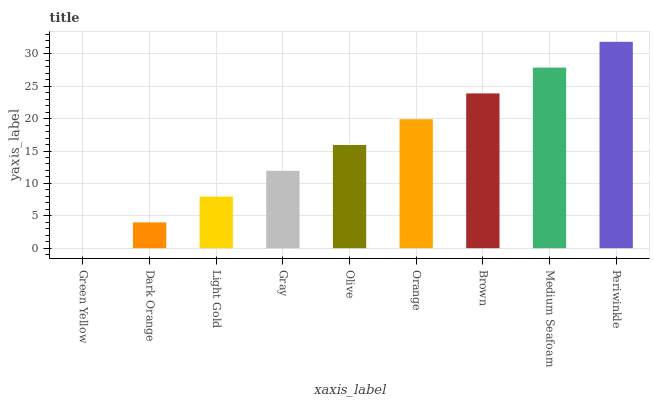Is Green Yellow the minimum?
Answer yes or no. Yes. Is Periwinkle the maximum?
Answer yes or no. Yes. Is Dark Orange the minimum?
Answer yes or no. No. Is Dark Orange the maximum?
Answer yes or no. No. Is Dark Orange greater than Green Yellow?
Answer yes or no. Yes. Is Green Yellow less than Dark Orange?
Answer yes or no. Yes. Is Green Yellow greater than Dark Orange?
Answer yes or no. No. Is Dark Orange less than Green Yellow?
Answer yes or no. No. Is Olive the high median?
Answer yes or no. Yes. Is Olive the low median?
Answer yes or no. Yes. Is Medium Seafoam the high median?
Answer yes or no. No. Is Gray the low median?
Answer yes or no. No. 